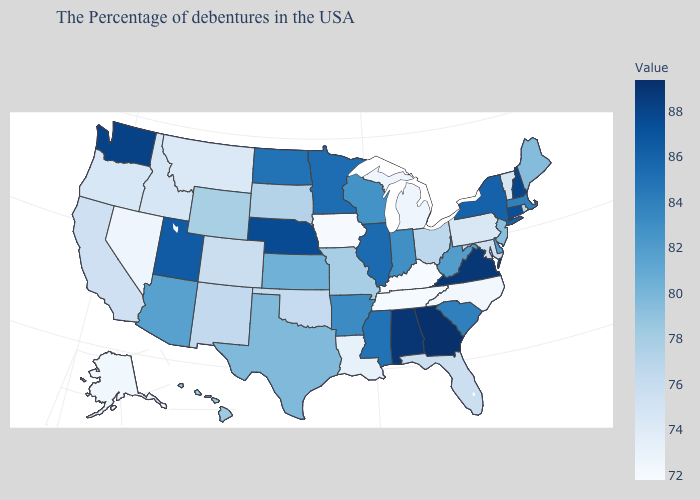Which states hav the highest value in the MidWest?
Give a very brief answer. Nebraska. Which states hav the highest value in the MidWest?
Quick response, please. Nebraska. Does Kentucky have the lowest value in the USA?
Answer briefly. Yes. Among the states that border New Hampshire , which have the highest value?
Concise answer only. Massachusetts. Does Iowa have the lowest value in the USA?
Short answer required. No. 